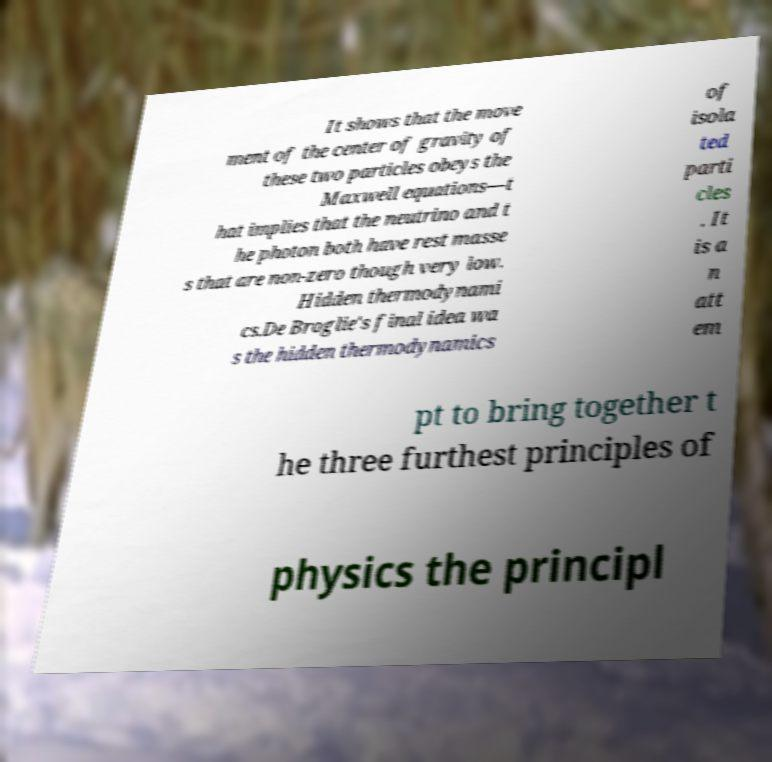Please identify and transcribe the text found in this image. It shows that the move ment of the center of gravity of these two particles obeys the Maxwell equations—t hat implies that the neutrino and t he photon both have rest masse s that are non-zero though very low. Hidden thermodynami cs.De Broglie's final idea wa s the hidden thermodynamics of isola ted parti cles . It is a n att em pt to bring together t he three furthest principles of physics the principl 